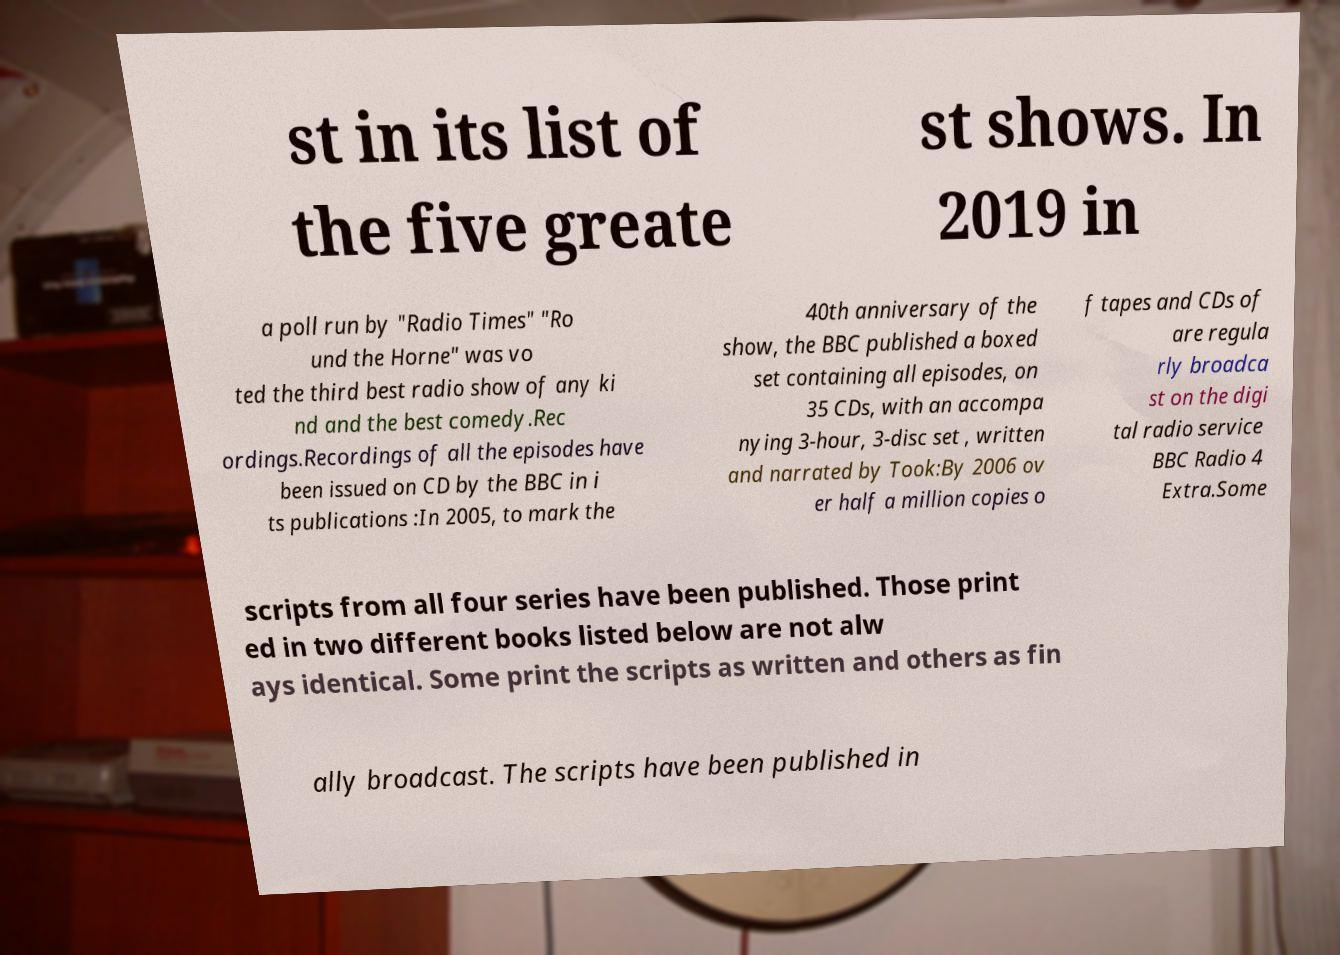Could you extract and type out the text from this image? st in its list of the five greate st shows. In 2019 in a poll run by "Radio Times" "Ro und the Horne" was vo ted the third best radio show of any ki nd and the best comedy.Rec ordings.Recordings of all the episodes have been issued on CD by the BBC in i ts publications :In 2005, to mark the 40th anniversary of the show, the BBC published a boxed set containing all episodes, on 35 CDs, with an accompa nying 3-hour, 3-disc set , written and narrated by Took:By 2006 ov er half a million copies o f tapes and CDs of are regula rly broadca st on the digi tal radio service BBC Radio 4 Extra.Some scripts from all four series have been published. Those print ed in two different books listed below are not alw ays identical. Some print the scripts as written and others as fin ally broadcast. The scripts have been published in 